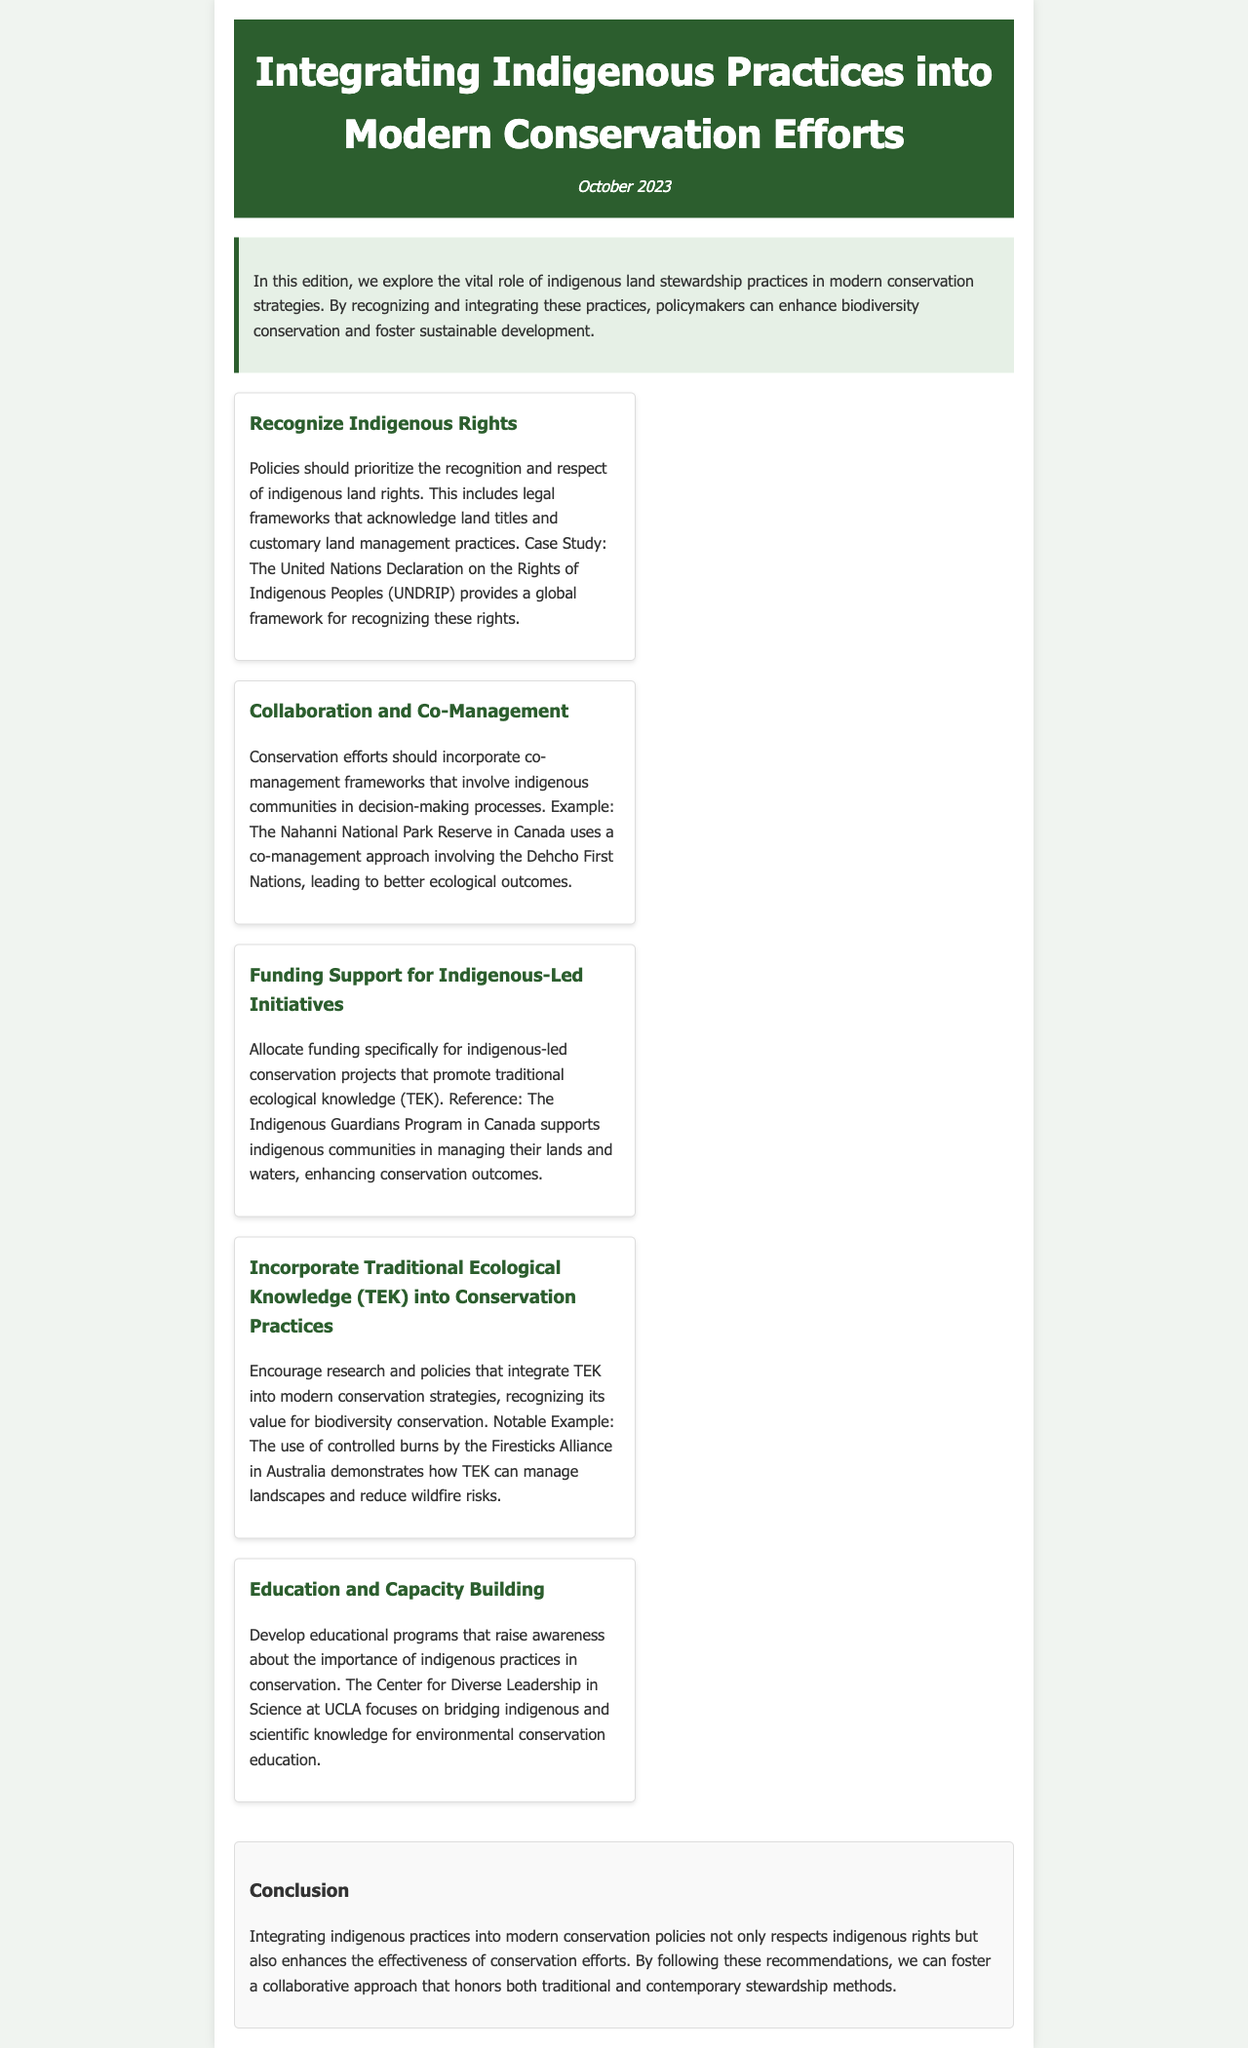What is the title of the newsletter? The title of the newsletter is given in the header of the document.
Answer: Integrating Indigenous Practices into Modern Conservation Efforts What is the date of publication? The date of publication is mentioned below the title in the header.
Answer: October 2023 What practice does the example of the Nahanni National Park Reserve illustrate? The example of the Nahanni National Park Reserve demonstrates a specific conservation approach discussed in the document.
Answer: Co-management What program supports indigenous communities in managing their lands in Canada? The document mentions a specific program aimed at funding indigenous-led initiatives.
Answer: Indigenous Guardians Program What is the main focus of the educational programs mentioned? The educational programs discussed in the newsletter aim to address a specific relationship in conservation.
Answer: Bridging indigenous and scientific knowledge Why is integrating Traditional Ecological Knowledge (TEK) emphasized in conservation practices? The document explains the benefits of using TEK in modern conservation strategies.
Answer: For biodiversity conservation Which document provides a global framework for recognizing indigenous rights? The newsletter mentions a specific declaration that outlines indigenous rights globally.
Answer: United Nations Declaration on the Rights of Indigenous Peoples What is one outcome of involving indigenous communities in decision-making? The document states that involving indigenous communities leads to specific results in conservation efforts.
Answer: Better ecological outcomes 